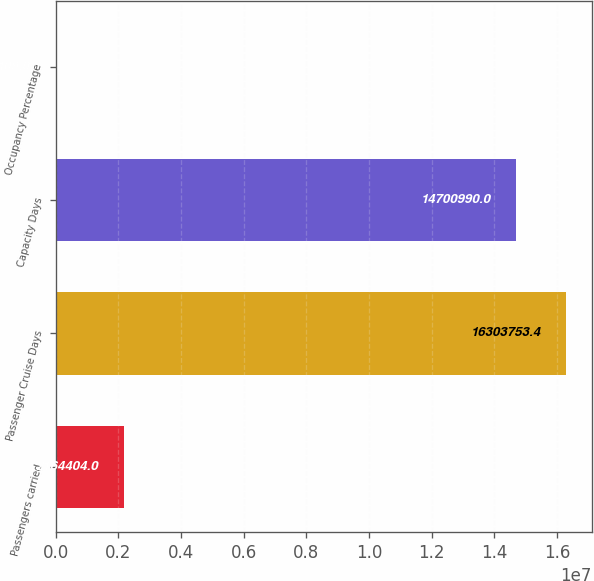Convert chart to OTSL. <chart><loc_0><loc_0><loc_500><loc_500><bar_chart><fcel>Passengers carried<fcel>Passenger Cruise Days<fcel>Capacity Days<fcel>Occupancy Percentage<nl><fcel>2.1644e+06<fcel>1.63038e+07<fcel>1.4701e+07<fcel>109<nl></chart> 